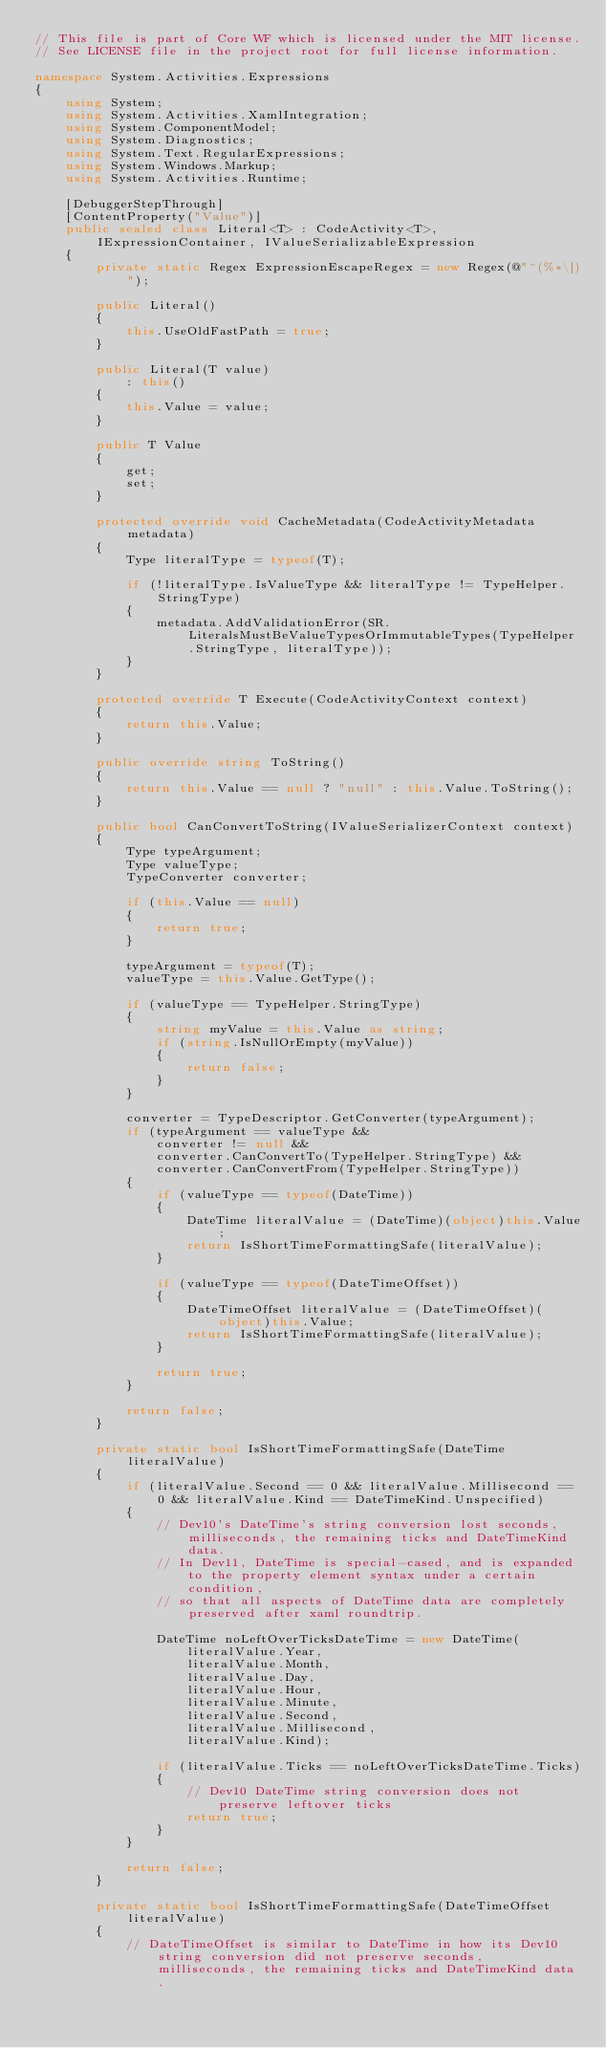<code> <loc_0><loc_0><loc_500><loc_500><_C#_>// This file is part of Core WF which is licensed under the MIT license.
// See LICENSE file in the project root for full license information.

namespace System.Activities.Expressions
{
    using System;
    using System.Activities.XamlIntegration;
    using System.ComponentModel;
    using System.Diagnostics;
    using System.Text.RegularExpressions;
    using System.Windows.Markup;
    using System.Activities.Runtime;

    [DebuggerStepThrough]
    [ContentProperty("Value")]
    public sealed class Literal<T> : CodeActivity<T>, IExpressionContainer, IValueSerializableExpression
    {
        private static Regex ExpressionEscapeRegex = new Regex(@"^(%*\[)");

        public Literal()
        {
            this.UseOldFastPath = true;
        }

        public Literal(T value)
            : this()
        {
            this.Value = value;
        }

        public T Value
        {
            get;
            set;
        }

        protected override void CacheMetadata(CodeActivityMetadata metadata)
        {
            Type literalType = typeof(T);

            if (!literalType.IsValueType && literalType != TypeHelper.StringType)
            {
                metadata.AddValidationError(SR.LiteralsMustBeValueTypesOrImmutableTypes(TypeHelper.StringType, literalType));
            }
        }

        protected override T Execute(CodeActivityContext context)
        {
            return this.Value;
        }

        public override string ToString()
        {
            return this.Value == null ? "null" : this.Value.ToString();
        }

        public bool CanConvertToString(IValueSerializerContext context)
        {
            Type typeArgument;
            Type valueType;
            TypeConverter converter;

            if (this.Value == null)
            {
                return true;
            }
            
            typeArgument = typeof(T);
            valueType = this.Value.GetType();

            if (valueType == TypeHelper.StringType)
            {
                string myValue = this.Value as string;
                if (string.IsNullOrEmpty(myValue))
                {
                    return false;
                }
            }          

            converter = TypeDescriptor.GetConverter(typeArgument);
            if (typeArgument == valueType &&
                converter != null && 
                converter.CanConvertTo(TypeHelper.StringType) && 
                converter.CanConvertFrom(TypeHelper.StringType))
            {               
                if (valueType == typeof(DateTime))
                {
                    DateTime literalValue = (DateTime)(object)this.Value;
                    return IsShortTimeFormattingSafe(literalValue);
                }

                if (valueType == typeof(DateTimeOffset))
                {
                    DateTimeOffset literalValue = (DateTimeOffset)(object)this.Value;
                    return IsShortTimeFormattingSafe(literalValue);
                }

                return true;
            }

            return false;
        }

        private static bool IsShortTimeFormattingSafe(DateTime literalValue)
        {
            if (literalValue.Second == 0 && literalValue.Millisecond == 0 && literalValue.Kind == DateTimeKind.Unspecified)
            {
                // Dev10's DateTime's string conversion lost seconds, milliseconds, the remaining ticks and DateTimeKind data.
                // In Dev11, DateTime is special-cased, and is expanded to the property element syntax under a certain condition,
                // so that all aspects of DateTime data are completely preserved after xaml roundtrip.

                DateTime noLeftOverTicksDateTime = new DateTime(
                    literalValue.Year,
                    literalValue.Month,
                    literalValue.Day,
                    literalValue.Hour,
                    literalValue.Minute,
                    literalValue.Second,
                    literalValue.Millisecond,
                    literalValue.Kind);

                if (literalValue.Ticks == noLeftOverTicksDateTime.Ticks)
                {
                    // Dev10 DateTime string conversion does not preserve leftover ticks
                    return true;
                }
            }

            return false;
        }

        private static bool IsShortTimeFormattingSafe(DateTimeOffset literalValue)
        {
            // DateTimeOffset is similar to DateTime in how its Dev10 string conversion did not preserve seconds, milliseconds, the remaining ticks and DateTimeKind data.</code> 